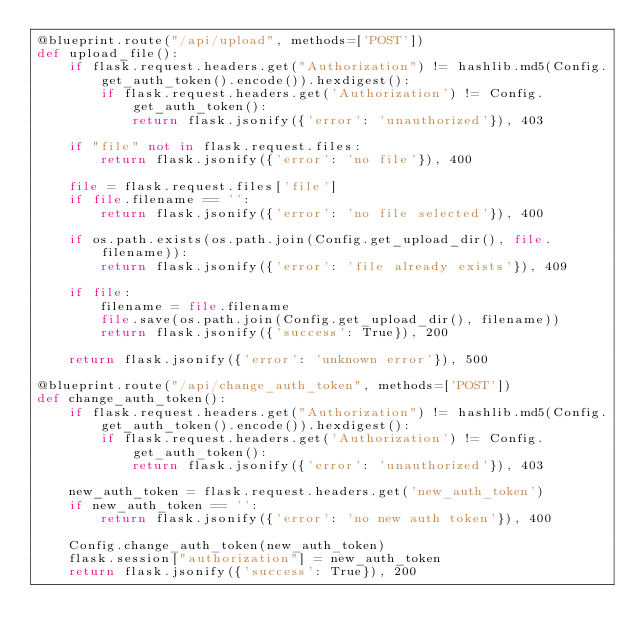Convert code to text. <code><loc_0><loc_0><loc_500><loc_500><_Python_>@blueprint.route("/api/upload", methods=['POST'])
def upload_file():
    if flask.request.headers.get("Authorization") != hashlib.md5(Config.get_auth_token().encode()).hexdigest():
        if flask.request.headers.get('Authorization') != Config.get_auth_token(): 
            return flask.jsonify({'error': 'unauthorized'}), 403

    if "file" not in flask.request.files:
        return flask.jsonify({'error': 'no file'}), 400

    file = flask.request.files['file']
    if file.filename == '':
        return flask.jsonify({'error': 'no file selected'}), 400

    if os.path.exists(os.path.join(Config.get_upload_dir(), file.filename)):
        return flask.jsonify({'error': 'file already exists'}), 409

    if file:
        filename = file.filename
        file.save(os.path.join(Config.get_upload_dir(), filename))
        return flask.jsonify({'success': True}), 200

    return flask.jsonify({'error': 'unknown error'}), 500

@blueprint.route("/api/change_auth_token", methods=['POST'])
def change_auth_token():
    if flask.request.headers.get("Authorization") != hashlib.md5(Config.get_auth_token().encode()).hexdigest():
        if flask.request.headers.get('Authorization') != Config.get_auth_token(): 
            return flask.jsonify({'error': 'unauthorized'}), 403

    new_auth_token = flask.request.headers.get('new_auth_token')
    if new_auth_token == '':
        return flask.jsonify({'error': 'no new auth token'}), 400

    Config.change_auth_token(new_auth_token)
    flask.session["authorization"] = new_auth_token
    return flask.jsonify({'success': True}), 200</code> 